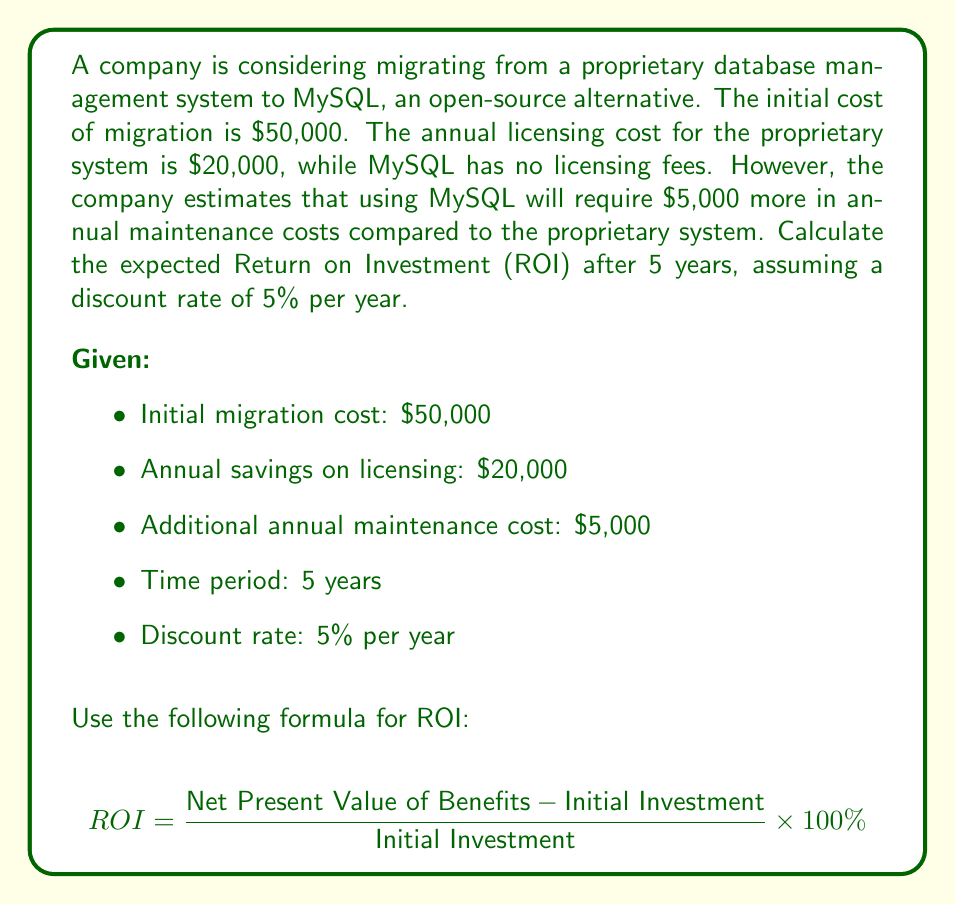What is the answer to this math problem? To solve this problem, we'll follow these steps:

1. Calculate the annual net savings:
   Annual net savings = Licensing savings - Additional maintenance cost
   $20,000 - $5,000 = $15,000

2. Calculate the present value of the net savings for each year:
   Present Value = Future Value / (1 + discount rate)^year

   Year 1: $15,000 / (1 + 0.05)^1 = $14,285.71
   Year 2: $15,000 / (1 + 0.05)^2 = $13,605.44
   Year 3: $15,000 / (1 + 0.05)^3 = $12,957.56
   Year 4: $15,000 / (1 + 0.05)^4 = $12,340.53
   Year 5: $15,000 / (1 + 0.05)^5 = $11,752.89

3. Sum up the present values:
   Total Present Value = $14,285.71 + $13,605.44 + $12,957.56 + $12,340.53 + $11,752.89
                       = $64,942.13

4. Calculate the Net Present Value of Benefits:
   Net Present Value = Total Present Value - Initial Investment
                     = $64,942.13 - $50,000 = $14,942.13

5. Calculate the ROI:
   $$ ROI = \frac{14,942.13}{50,000} \times 100\% = 29.88\% $$

Therefore, the expected ROI after 5 years is approximately 29.88%.
Answer: 29.88% 